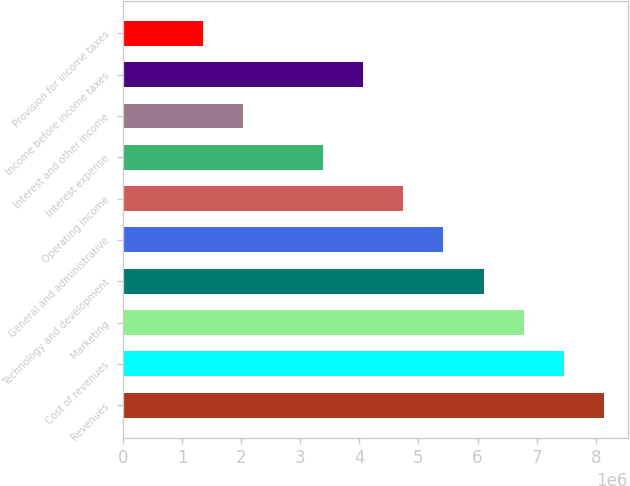<chart> <loc_0><loc_0><loc_500><loc_500><bar_chart><fcel>Revenues<fcel>Cost of revenues<fcel>Marketing<fcel>Technology and development<fcel>General and administrative<fcel>Operating income<fcel>Interest expense<fcel>Interest and other income<fcel>Income before income taxes<fcel>Provision for income taxes<nl><fcel>8.13541e+06<fcel>7.45746e+06<fcel>6.77951e+06<fcel>6.10156e+06<fcel>5.42361e+06<fcel>4.74566e+06<fcel>3.38976e+06<fcel>2.03385e+06<fcel>4.06771e+06<fcel>1.3559e+06<nl></chart> 